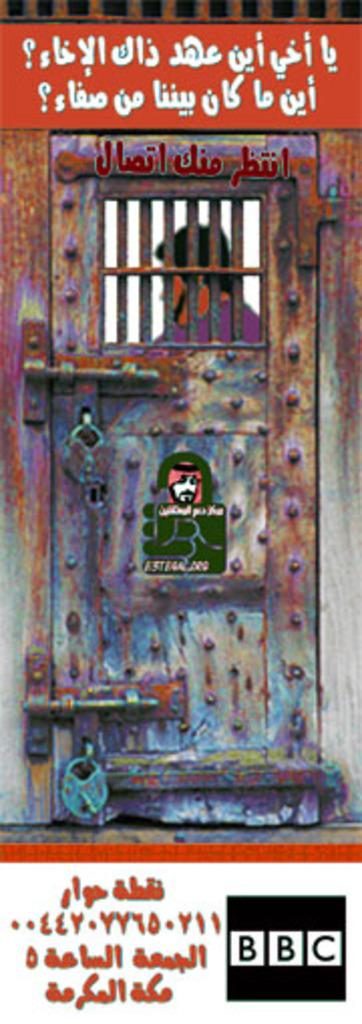<image>
Write a terse but informative summary of the picture. A photo featuring a man behind a jail cell door is sponsored by the BBC. 